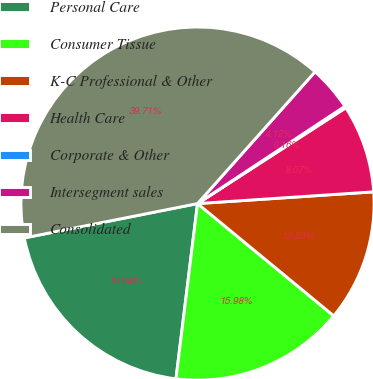Convert chart. <chart><loc_0><loc_0><loc_500><loc_500><pie_chart><fcel>Personal Care<fcel>Consumer Tissue<fcel>K-C Professional & Other<fcel>Health Care<fcel>Corporate & Other<fcel>Intersegment sales<fcel>Consolidated<nl><fcel>19.94%<fcel>15.98%<fcel>12.03%<fcel>8.07%<fcel>0.16%<fcel>4.12%<fcel>39.71%<nl></chart> 